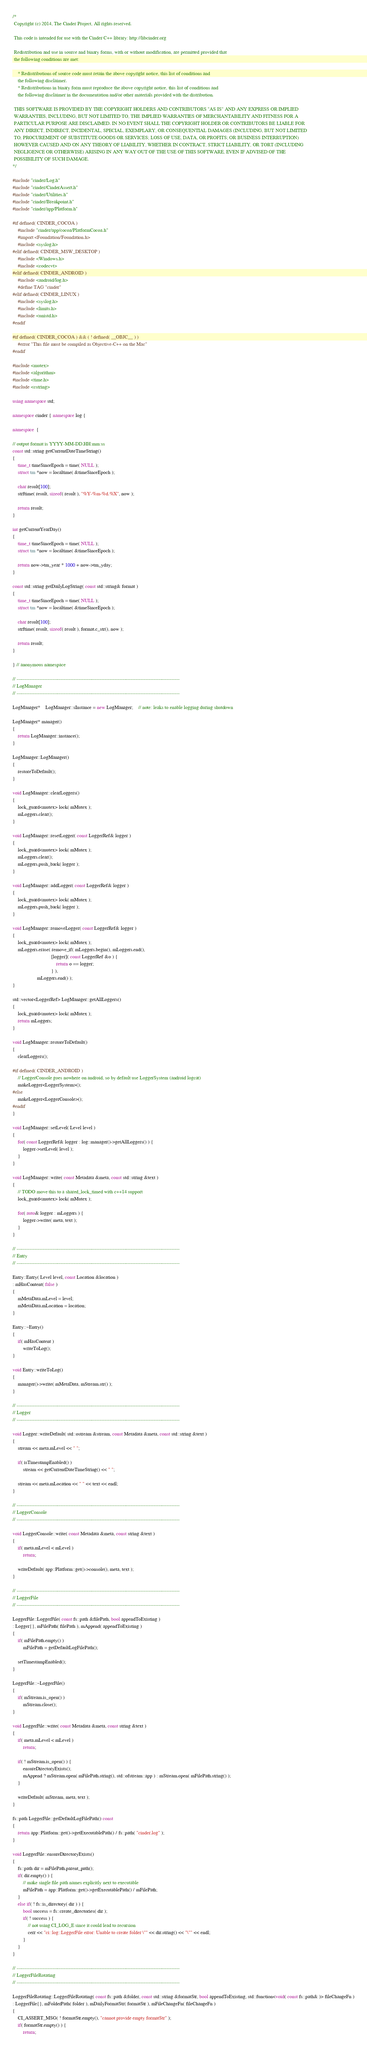<code> <loc_0><loc_0><loc_500><loc_500><_C++_>/*
 Copyright (c) 2014, The Cinder Project, All rights reserved.

 This code is intended for use with the Cinder C++ library: http://libcinder.org

 Redistribution and use in source and binary forms, with or without modification, are permitted provided that
 the following conditions are met:

    * Redistributions of source code must retain the above copyright notice, this list of conditions and
	the following disclaimer.
    * Redistributions in binary form must reproduce the above copyright notice, this list of conditions and
	the following disclaimer in the documentation and/or other materials provided with the distribution.

 THIS SOFTWARE IS PROVIDED BY THE COPYRIGHT HOLDERS AND CONTRIBUTORS "AS IS" AND ANY EXPRESS OR IMPLIED
 WARRANTIES, INCLUDING, BUT NOT LIMITED TO, THE IMPLIED WARRANTIES OF MERCHANTABILITY AND FITNESS FOR A
 PARTICULAR PURPOSE ARE DISCLAIMED. IN NO EVENT SHALL THE COPYRIGHT HOLDER OR CONTRIBUTORS BE LIABLE FOR
 ANY DIRECT, INDIRECT, INCIDENTAL, SPECIAL, EXEMPLARY, OR CONSEQUENTIAL DAMAGES (INCLUDING, BUT NOT LIMITED
 TO, PROCUREMENT OF SUBSTITUTE GOODS OR SERVICES; LOSS OF USE, DATA, OR PROFITS; OR BUSINESS INTERRUPTION)
 HOWEVER CAUSED AND ON ANY THEORY OF LIABILITY, WHETHER IN CONTRACT, STRICT LIABILITY, OR TORT (INCLUDING
 NEGLIGENCE OR OTHERWISE) ARISING IN ANY WAY OUT OF THE USE OF THIS SOFTWARE, EVEN IF ADVISED OF THE
 POSSIBILITY OF SUCH DAMAGE.
*/

#include "cinder/Log.h"
#include "cinder/CinderAssert.h"
#include "cinder/Utilities.h"
#include "cinder/Breakpoint.h"
#include "cinder/app/Platform.h"

#if defined( CINDER_COCOA )
	#include "cinder/app/cocoa/PlatformCocoa.h"
	#import <Foundation/Foundation.h>
	#include <syslog.h>
#elif defined( CINDER_MSW_DESKTOP )
	#include <Windows.h>
	#include <codecvt>
#elif defined( CINDER_ANDROID )
	#include <android/log.h>
 	#define TAG "cinder"
#elif defined( CINDER_LINUX )
	#include <syslog.h>
	#include <limits.h>
	#include <unistd.h>
#endif

#if defined( CINDER_COCOA ) && ( ! defined( __OBJC__ ) )
	#error "This file must be compiled as Objective-C++ on the Mac"
#endif

#include <mutex>
#include <algorithm>
#include <time.h>
#include <cstring>

using namespace std;

namespace cinder { namespace log {

namespace  {

// output format is YYYY-MM-DD.HH:mm:ss
const std::string getCurrentDateTimeString()
{
	time_t timeSinceEpoch = time( NULL );
	struct tm *now = localtime( &timeSinceEpoch );

	char result[100];
	strftime( result, sizeof( result ), "%Y-%m-%d.%X", now );

	return result;
}

int getCurrentYearDay()
{
	time_t timeSinceEpoch = time( NULL );
	struct tm *now = localtime( &timeSinceEpoch );

	return now->tm_year * 1000 + now->tm_yday;
}

const std::string getDailyLogString( const std::string& format )
{
	time_t timeSinceEpoch = time( NULL );
	struct tm *now = localtime( &timeSinceEpoch );

	char result[100];
	strftime( result, sizeof( result ), format.c_str(), now );

	return result;
}

} // anonymous namespace

// ----------------------------------------------------------------------------------------------------
// LogManager
// ----------------------------------------------------------------------------------------------------

LogManager*	LogManager::sInstance = new LogManager;	// note: leaks to enable logging during shutdown

LogManager* manager()
{
	return LogManager::instance();
}

LogManager::LogManager()
{
	restoreToDefault();
}

void LogManager::clearLoggers()
{
	lock_guard<mutex> lock( mMutex );
	mLoggers.clear();
}
	
void LogManager::resetLogger( const LoggerRef& logger )
{
	lock_guard<mutex> lock( mMutex );
	mLoggers.clear();
	mLoggers.push_back( logger );
}

void LogManager::addLogger( const LoggerRef& logger )
{
	lock_guard<mutex> lock( mMutex );
	mLoggers.push_back( logger );
}

void LogManager::removeLogger( const LoggerRef& logger )
{
	lock_guard<mutex> lock( mMutex );
	mLoggers.erase( remove_if( mLoggers.begin(), mLoggers.end(),
							  [logger]( const LoggerRef &o ) {
								  return o == logger;
							  } ),
				   mLoggers.end() );
}

std::vector<LoggerRef> LogManager::getAllLoggers()
{
	lock_guard<mutex> lock( mMutex );
	return mLoggers;
}
	
void LogManager::restoreToDefault()
{
	clearLoggers();

#if defined( CINDER_ANDROID )
	// LoggerConsole goes nowhere on android, so by default use LoggerSystem (android logcat)
	makeLogger<LoggerSystem>();
#else
	makeLogger<LoggerConsole>();
#endif
}
	
void LogManager::setLevel( Level level )
{
	for( const LoggerRef& logger : log::manager()->getAllLoggers() ) {
		logger->setLevel( level );
	}
}

void LogManager::write( const Metadata &meta, const std::string &text )
{
	// TODO move this to a shared_lock_timed with c++14 support
	lock_guard<mutex> lock( mMutex );

	for( auto& logger : mLoggers ) {
		logger->write( meta, text );
	}
}

// ----------------------------------------------------------------------------------------------------
// Entry
// ----------------------------------------------------------------------------------------------------

Entry::Entry( Level level, const Location &location )
: mHasContent( false )
{
	mMetaData.mLevel = level;
	mMetaData.mLocation = location;
}

Entry::~Entry()
{
	if( mHasContent )
		writeToLog();
}

void Entry::writeToLog()
{
	manager()->write( mMetaData, mStream.str() );
}

// ----------------------------------------------------------------------------------------------------
// Logger
// ----------------------------------------------------------------------------------------------------

void Logger::writeDefault( std::ostream &stream, const Metadata &meta, const std::string &text )
{
	stream << meta.mLevel << " ";

	if( isTimestampEnabled() )
		stream << getCurrentDateTimeString() << " ";

	stream << meta.mLocation << " " << text << endl;
}

// ----------------------------------------------------------------------------------------------------
// LoggerConsole
// ----------------------------------------------------------------------------------------------------

void LoggerConsole::write( const Metadata &meta, const string &text )
{
	if( meta.mLevel < mLevel )
		return;

	writeDefault( app::Platform::get()->console(), meta, text );
}

// ----------------------------------------------------------------------------------------------------
// LoggerFile
// ----------------------------------------------------------------------------------------------------

LoggerFile::LoggerFile( const fs::path &filePath, bool appendToExisting )
: Logger{}, mFilePath( filePath ), mAppend( appendToExisting )
{
	if( mFilePath.empty() )
		mFilePath = getDefaultLogFilePath();
	
	setTimestampEnabled();
}

LoggerFile::~LoggerFile()
{
	if( mStream.is_open() )
		mStream.close();
}

void LoggerFile::write( const Metadata &meta, const string &text )
{
	if( meta.mLevel < mLevel )
		return;

	if( ! mStream.is_open() ) {
		ensureDirectoryExists();
		mAppend ? mStream.open( mFilePath.string(), std::ofstream::app ) : mStream.open( mFilePath.string() );
	}
	
	writeDefault( mStream, meta, text );
}

fs::path LoggerFile::getDefaultLogFilePath() const
{
	return app::Platform::get()->getExecutablePath() / fs::path( "cinder.log" );
}

void LoggerFile::ensureDirectoryExists()
{
	fs::path dir = mFilePath.parent_path();
	if( dir.empty() ) {
		// make single file path names explicitly next to executable
		mFilePath = app::Platform::get()->getExecutablePath() / mFilePath;
	}
	else if( ! fs::is_directory( dir ) ) {
		bool success = fs::create_directories( dir );
		if( ! success ) {
			// not using CI_LOG_E since it could lead to recursion
			cerr << "ci::log::LoggerFile error: Unable to create folder \"" << dir.string() << "\"" << endl;
		}
	}
}

// ----------------------------------------------------------------------------------------------------
// LoggerFileRotating
// ----------------------------------------------------------------------------------------------------

LoggerFileRotating::LoggerFileRotating( const fs::path &folder, const std::string &formatStr, bool appendToExisting, std::function<void( const fs::path& )> fileChangeFn )
: LoggerFile{}, mFolderPath( folder ), mDailyFormatStr( formatStr ), mFileChangeFn( fileChangeFn )
{
	CI_ASSERT_MSG( ! formatStr.empty(), "cannot provide empty formatStr" );
	if( formatStr.empty() ) {
		return;</code> 